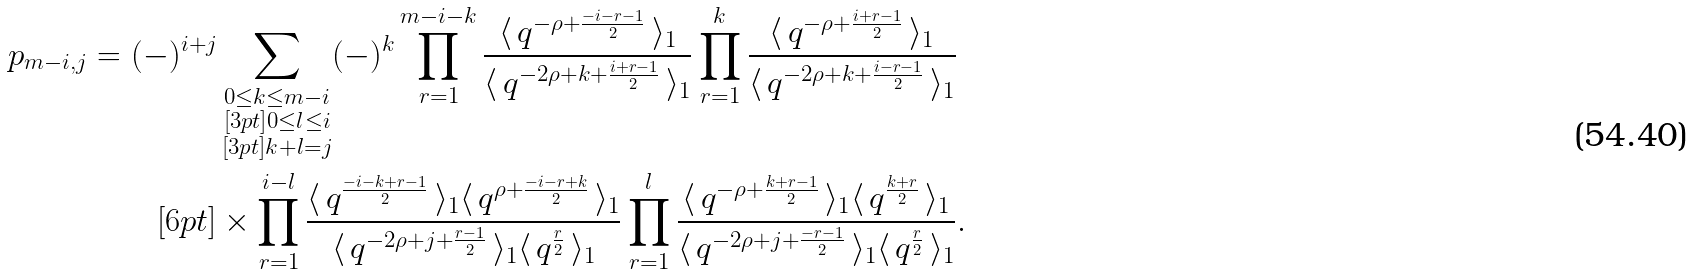Convert formula to latex. <formula><loc_0><loc_0><loc_500><loc_500>p _ { m - i , j } = ( - ) ^ { i + j } & \sum _ { \substack { 0 \leq k \leq m - i \\ [ 3 p t ] 0 \leq l \leq i \\ [ 3 p t ] k + l = j } } ( - ) ^ { k } \prod _ { r = 1 } ^ { m - i - k } \frac { \langle \, q ^ { - \rho + \frac { - i - r - 1 } { 2 } } \, \rangle _ { 1 } } { \langle \, q ^ { - 2 \rho + k + \frac { i + r - 1 } { 2 } } \, \rangle _ { 1 } } \prod _ { r = 1 } ^ { k } \frac { \langle \, q ^ { - \rho + \frac { i + r - 1 } { 2 } } \, \rangle _ { 1 } } { \langle \, q ^ { - 2 \rho + k + \frac { i - r - 1 } { 2 } } \, \rangle _ { 1 } } \\ [ 6 p t ] & \times \prod _ { r = 1 } ^ { i - l } \frac { \langle \, q ^ { \frac { - i - k + r - 1 } { 2 } } \, \rangle _ { 1 } \langle \, q ^ { \rho + \frac { - i - r + k } { 2 } } \, \rangle _ { 1 } } { \langle \, q ^ { - 2 \rho + j + \frac { r - 1 } { 2 } } \, \rangle _ { 1 } \langle \, q ^ { \frac { r } { 2 } } \, \rangle _ { 1 } } \prod _ { r = 1 } ^ { l } \frac { \langle \, q ^ { - \rho + \frac { k + r - 1 } { 2 } } \, \rangle _ { 1 } \langle \, q ^ { \frac { k + r } { 2 } } \, \rangle _ { 1 } } { \langle \, q ^ { - 2 \rho + j + \frac { - r - 1 } { 2 } } \, \rangle _ { 1 } \langle \, q ^ { \frac { r } { 2 } } \, \rangle _ { 1 } } .</formula> 